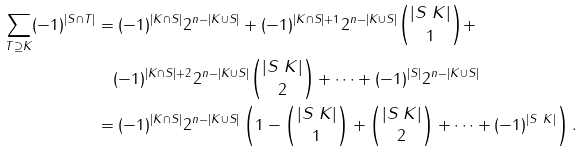<formula> <loc_0><loc_0><loc_500><loc_500>\sum _ { T \supseteq K } ( - 1 ) ^ { | S \cap T | } & = ( - 1 ) ^ { | K \cap S | } 2 ^ { n - | K \cup S | } + ( - 1 ) ^ { | K \cap S | + 1 } 2 ^ { n - | K \cup S | } \binom { | S \ K | } { 1 } + \\ & \quad ( - 1 ) ^ { | K \cap S | + 2 } 2 ^ { n - | K \cup S | } \binom { | S \ K | } { 2 } + \cdots + ( - 1 ) ^ { | S | } 2 ^ { n - | K \cup S | } \\ & = ( - 1 ) ^ { | K \cap S | } 2 ^ { n - | K \cup S | } \left ( 1 - \binom { | S \ K | } { 1 } + \binom { | S \ K | } { 2 } + \cdots + ( - 1 ) ^ { | S \ K | } \right ) .</formula> 